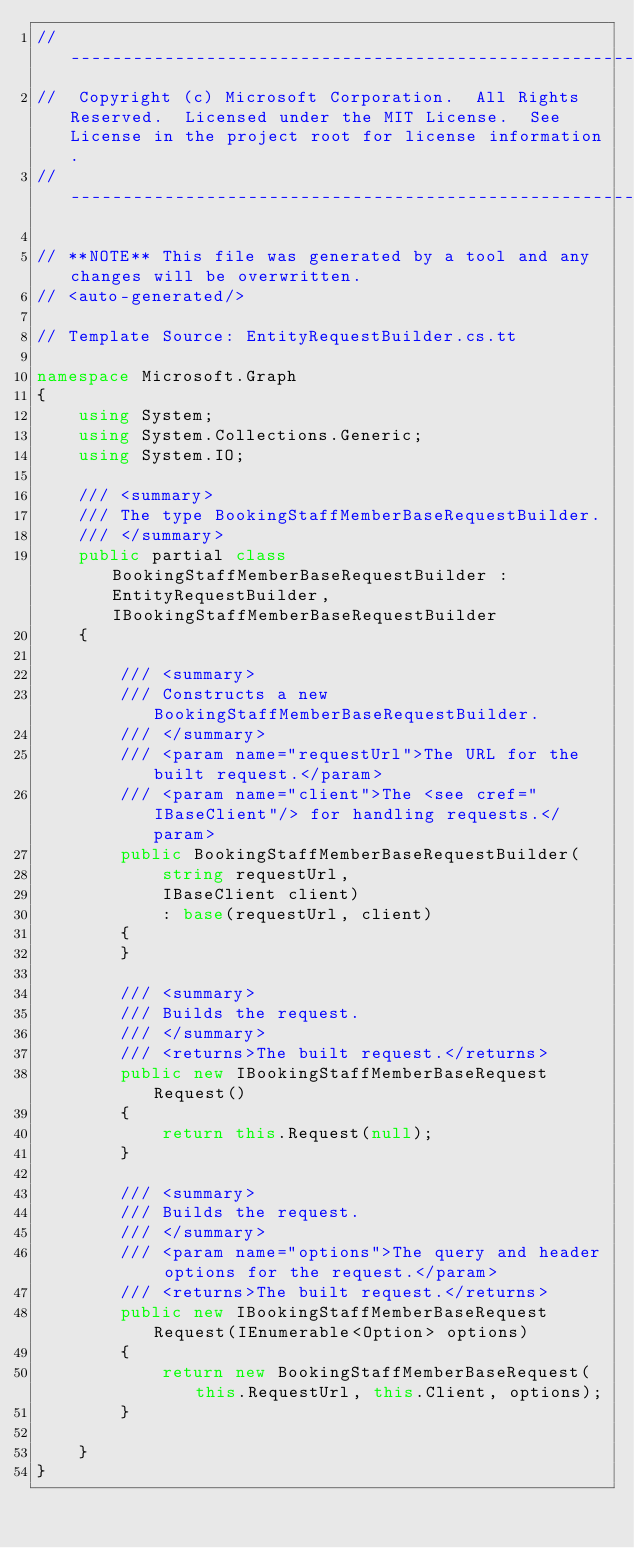<code> <loc_0><loc_0><loc_500><loc_500><_C#_>// ------------------------------------------------------------------------------
//  Copyright (c) Microsoft Corporation.  All Rights Reserved.  Licensed under the MIT License.  See License in the project root for license information.
// ------------------------------------------------------------------------------

// **NOTE** This file was generated by a tool and any changes will be overwritten.
// <auto-generated/>

// Template Source: EntityRequestBuilder.cs.tt

namespace Microsoft.Graph
{
    using System;
    using System.Collections.Generic;
    using System.IO;

    /// <summary>
    /// The type BookingStaffMemberBaseRequestBuilder.
    /// </summary>
    public partial class BookingStaffMemberBaseRequestBuilder : EntityRequestBuilder, IBookingStaffMemberBaseRequestBuilder
    {

        /// <summary>
        /// Constructs a new BookingStaffMemberBaseRequestBuilder.
        /// </summary>
        /// <param name="requestUrl">The URL for the built request.</param>
        /// <param name="client">The <see cref="IBaseClient"/> for handling requests.</param>
        public BookingStaffMemberBaseRequestBuilder(
            string requestUrl,
            IBaseClient client)
            : base(requestUrl, client)
        {
        }

        /// <summary>
        /// Builds the request.
        /// </summary>
        /// <returns>The built request.</returns>
        public new IBookingStaffMemberBaseRequest Request()
        {
            return this.Request(null);
        }

        /// <summary>
        /// Builds the request.
        /// </summary>
        /// <param name="options">The query and header options for the request.</param>
        /// <returns>The built request.</returns>
        public new IBookingStaffMemberBaseRequest Request(IEnumerable<Option> options)
        {
            return new BookingStaffMemberBaseRequest(this.RequestUrl, this.Client, options);
        }
    
    }
}
</code> 